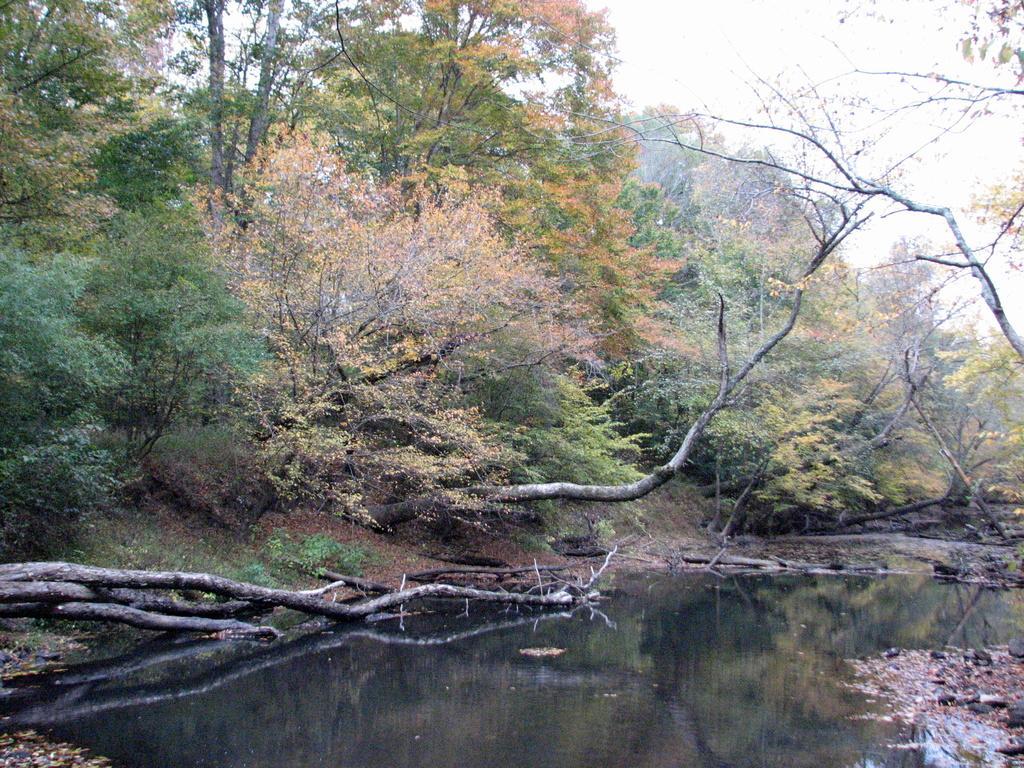How would you summarize this image in a sentence or two? In front of the image there is water. There are branches of a tree, rocks. In the background of the image there are trees. At the top of the image there is sky. 